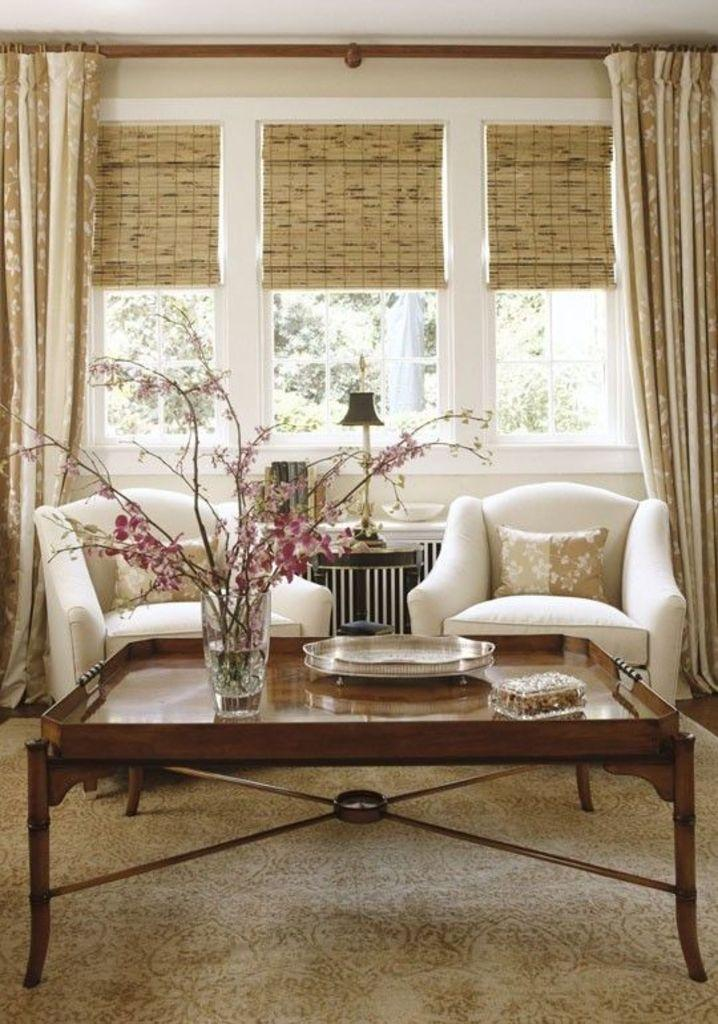What piece of furniture is present in the image? There is a table in the image. What is placed on the table? There is a flower vase on the table. What type of seating is visible in the image? There is a chair in the image. What is on the chair? There is a pillow on the chair. What type of window treatment is present in the image? There is a curtain in the image. What architectural feature is visible in the image? There is a window in the image. What can be seen through the window? There is a tree visible through the window. How many bags can be seen hanging on the tree outside the window? There are no bags visible on the tree outside the window; only the tree is visible through the window. What type of fish is swimming in the flower vase on the table? There are no fish present in the image; the flower vase contains flowers, not fish. 